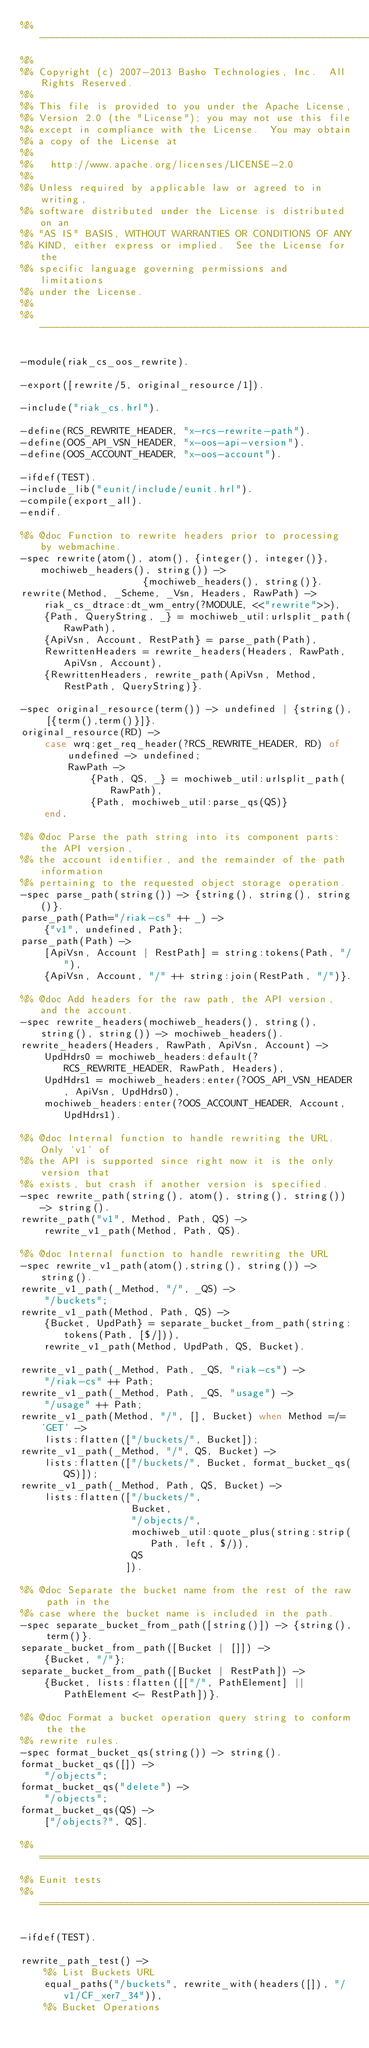Convert code to text. <code><loc_0><loc_0><loc_500><loc_500><_Erlang_>%% ---------------------------------------------------------------------
%%
%% Copyright (c) 2007-2013 Basho Technologies, Inc.  All Rights Reserved.
%%
%% This file is provided to you under the Apache License,
%% Version 2.0 (the "License"); you may not use this file
%% except in compliance with the License.  You may obtain
%% a copy of the License at
%%
%%   http://www.apache.org/licenses/LICENSE-2.0
%%
%% Unless required by applicable law or agreed to in writing,
%% software distributed under the License is distributed on an
%% "AS IS" BASIS, WITHOUT WARRANTIES OR CONDITIONS OF ANY
%% KIND, either express or implied.  See the License for the
%% specific language governing permissions and limitations
%% under the License.
%%
%% ---------------------------------------------------------------------

-module(riak_cs_oos_rewrite).

-export([rewrite/5, original_resource/1]).

-include("riak_cs.hrl").

-define(RCS_REWRITE_HEADER, "x-rcs-rewrite-path").
-define(OOS_API_VSN_HEADER, "x-oos-api-version").
-define(OOS_ACCOUNT_HEADER, "x-oos-account").

-ifdef(TEST).
-include_lib("eunit/include/eunit.hrl").
-compile(export_all).
-endif.

%% @doc Function to rewrite headers prior to processing by webmachine.
-spec rewrite(atom(), atom(), {integer(), integer()}, mochiweb_headers(), string()) ->
                     {mochiweb_headers(), string()}.
rewrite(Method, _Scheme, _Vsn, Headers, RawPath) ->
    riak_cs_dtrace:dt_wm_entry(?MODULE, <<"rewrite">>),
    {Path, QueryString, _} = mochiweb_util:urlsplit_path(RawPath),
    {ApiVsn, Account, RestPath} = parse_path(Path),
    RewrittenHeaders = rewrite_headers(Headers, RawPath, ApiVsn, Account),
    {RewrittenHeaders, rewrite_path(ApiVsn, Method, RestPath, QueryString)}.

-spec original_resource(term()) -> undefined | {string(), [{term(),term()}]}.
original_resource(RD) ->
    case wrq:get_req_header(?RCS_REWRITE_HEADER, RD) of
        undefined -> undefined;
        RawPath ->
            {Path, QS, _} = mochiweb_util:urlsplit_path(RawPath),
            {Path, mochiweb_util:parse_qs(QS)}
    end.

%% @doc Parse the path string into its component parts: the API version,
%% the account identifier, and the remainder of the path information
%% pertaining to the requested object storage operation.
-spec parse_path(string()) -> {string(), string(), string()}.
parse_path(Path="/riak-cs" ++ _) ->
    {"v1", undefined, Path};
parse_path(Path) ->
    [ApiVsn, Account | RestPath] = string:tokens(Path, "/"),
    {ApiVsn, Account, "/" ++ string:join(RestPath, "/")}.

%% @doc Add headers for the raw path, the API version, and the account.
-spec rewrite_headers(mochiweb_headers(), string(), string(), string()) -> mochiweb_headers().
rewrite_headers(Headers, RawPath, ApiVsn, Account) ->
    UpdHdrs0 = mochiweb_headers:default(?RCS_REWRITE_HEADER, RawPath, Headers),
    UpdHdrs1 = mochiweb_headers:enter(?OOS_API_VSN_HEADER, ApiVsn, UpdHdrs0),
    mochiweb_headers:enter(?OOS_ACCOUNT_HEADER, Account, UpdHdrs1).

%% @doc Internal function to handle rewriting the URL. Only `v1' of
%% the API is supported since right now it is the only version that
%% exists, but crash if another version is specified.
-spec rewrite_path(string(), atom(), string(), string()) -> string().
rewrite_path("v1", Method, Path, QS) ->
    rewrite_v1_path(Method, Path, QS).

%% @doc Internal function to handle rewriting the URL
-spec rewrite_v1_path(atom(),string(), string()) -> string().
rewrite_v1_path(_Method, "/", _QS) ->
    "/buckets";
rewrite_v1_path(Method, Path, QS) ->
    {Bucket, UpdPath} = separate_bucket_from_path(string:tokens(Path, [$/])),
    rewrite_v1_path(Method, UpdPath, QS, Bucket).

rewrite_v1_path(_Method, Path, _QS, "riak-cs") ->
    "/riak-cs" ++ Path;
rewrite_v1_path(_Method, Path, _QS, "usage") ->
    "/usage" ++ Path;
rewrite_v1_path(Method, "/", [], Bucket) when Method =/= 'GET' ->
    lists:flatten(["/buckets/", Bucket]);
rewrite_v1_path(_Method, "/", QS, Bucket) ->
    lists:flatten(["/buckets/", Bucket, format_bucket_qs(QS)]);
rewrite_v1_path(_Method, Path, QS, Bucket) ->
    lists:flatten(["/buckets/",
                   Bucket,
                   "/objects/",
                   mochiweb_util:quote_plus(string:strip(Path, left, $/)),
                   QS
                  ]).

%% @doc Separate the bucket name from the rest of the raw path in the
%% case where the bucket name is included in the path.
-spec separate_bucket_from_path([string()]) -> {string(), term()}.
separate_bucket_from_path([Bucket | []]) ->
    {Bucket, "/"};
separate_bucket_from_path([Bucket | RestPath]) ->
    {Bucket, lists:flatten([["/", PathElement] || PathElement <- RestPath])}.

%% @doc Format a bucket operation query string to conform the the
%% rewrite rules.
-spec format_bucket_qs(string()) -> string().
format_bucket_qs([]) ->
    "/objects";
format_bucket_qs("delete") ->
    "/objects";
format_bucket_qs(QS) ->
    ["/objects?", QS].

%% ===================================================================
%% Eunit tests
%% ===================================================================

-ifdef(TEST).

rewrite_path_test() ->
    %% List Buckets URL
    equal_paths("/buckets", rewrite_with(headers([]), "/v1/CF_xer7_34")),
    %% Bucket Operations</code> 